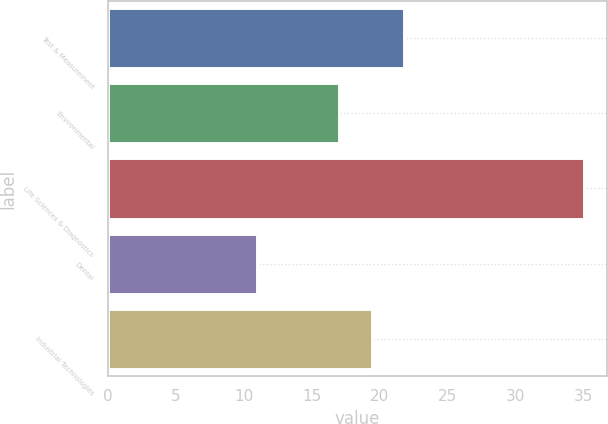<chart> <loc_0><loc_0><loc_500><loc_500><bar_chart><fcel>Test & Measurement<fcel>Environmental<fcel>Life Sciences & Diagnostics<fcel>Dental<fcel>Industrial Technologies<nl><fcel>21.8<fcel>17<fcel>35<fcel>11<fcel>19.4<nl></chart> 